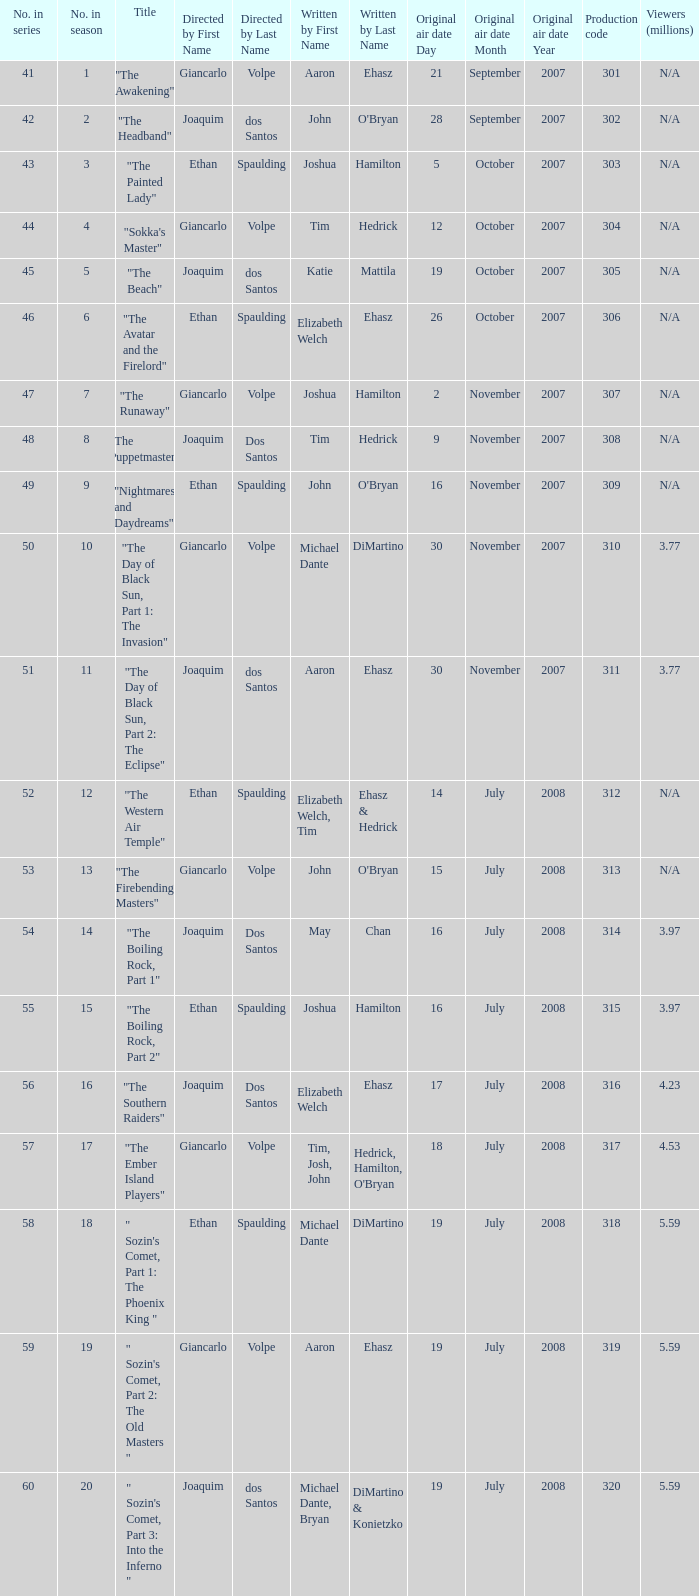How many viewers in millions for episode "sokka's master"? N/A. 